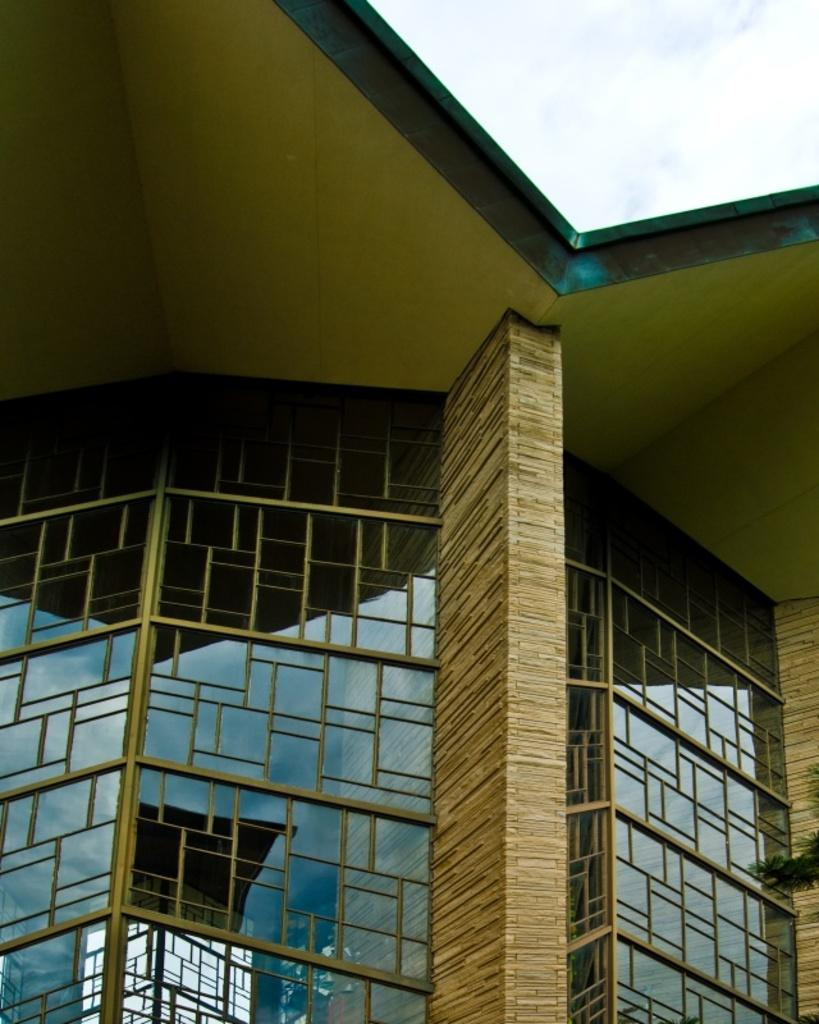What type of structure is visible in the image? There is a building in the image. What material covers the front of the building? The front of the building is covered with glass. Can you describe any architectural features of the building? There is a pillar present in the middle of the building. What can be seen in the sky in the image? Clouds are visible in the sky. How many brothers are standing next to the pillar in the image? There are no brothers present in the image; it only features a building with a pillar. What type of bells can be heard ringing in the image? There are no bells present in the image, and therefore no sound can be heard. 